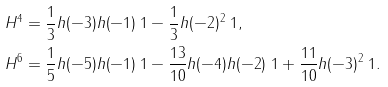<formula> <loc_0><loc_0><loc_500><loc_500>H ^ { 4 } & = \frac { 1 } { 3 } h ( - 3 ) h ( - 1 ) \ 1 - \frac { 1 } { 3 } h ( - 2 ) ^ { 2 } \ 1 , \\ H ^ { 6 } & = \frac { 1 } { 5 } h ( - 5 ) h ( - 1 ) \ 1 - \frac { 1 3 } { 1 0 } h ( - 4 ) h ( - 2 ) \ 1 + \frac { 1 1 } { 1 0 } h ( - 3 ) ^ { 2 } \ 1 .</formula> 